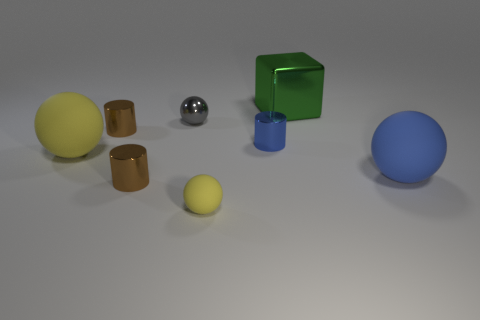There is a object that is the same color as the tiny rubber sphere; what size is it?
Provide a short and direct response. Large. What material is the other sphere that is the same color as the tiny matte sphere?
Provide a short and direct response. Rubber. What number of other objects are there of the same color as the tiny shiny ball?
Your answer should be very brief. 0. Do the yellow thing behind the big blue sphere and the large green object have the same material?
Make the answer very short. No. Is the number of tiny gray balls behind the green shiny cube less than the number of brown objects that are to the right of the gray shiny thing?
Your response must be concise. No. What number of other objects are there of the same material as the large yellow thing?
Offer a very short reply. 2. There is a blue cylinder that is the same size as the gray shiny object; what is its material?
Your answer should be very brief. Metal. Is the number of large rubber spheres on the right side of the gray thing less than the number of gray metal balls?
Give a very brief answer. No. What is the shape of the small brown object that is right of the brown metallic cylinder behind the ball to the right of the large green block?
Your answer should be compact. Cylinder. What is the size of the matte ball on the right side of the tiny yellow matte sphere?
Give a very brief answer. Large. 